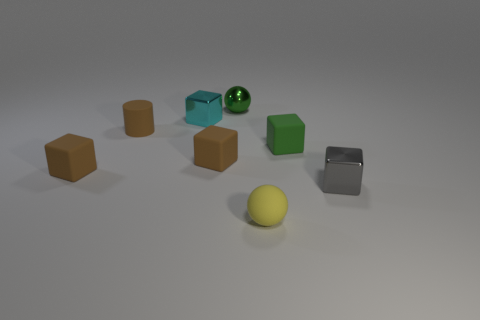The matte ball has what color?
Offer a very short reply. Yellow. There is a gray thing that is made of the same material as the tiny green ball; what shape is it?
Keep it short and to the point. Cube. There is a tiny green cube; how many metal things are to the left of it?
Make the answer very short. 2. Is there a brown object?
Keep it short and to the point. Yes. There is a ball that is behind the yellow object on the right side of the ball behind the matte cylinder; what is its color?
Ensure brevity in your answer.  Green. Are there any metal cubes that are on the right side of the brown rubber object that is on the right side of the tiny cyan shiny object?
Make the answer very short. Yes. Does the tiny matte cube that is on the left side of the cyan cube have the same color as the small matte object that is behind the tiny green cube?
Ensure brevity in your answer.  Yes. How many brown objects have the same size as the green rubber block?
Provide a short and direct response. 3. Is the size of the thing that is in front of the gray shiny cube the same as the cyan object?
Give a very brief answer. Yes. There is a yellow matte thing; what shape is it?
Ensure brevity in your answer.  Sphere. 